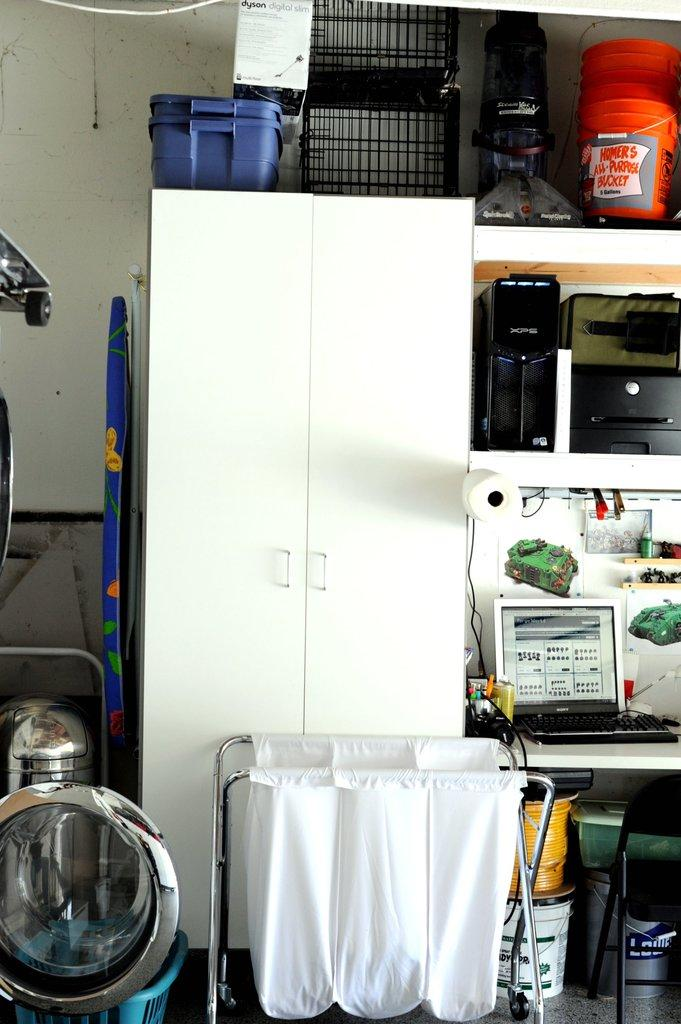<image>
Create a compact narrative representing the image presented. a utility room with various storage containers and orange buckets by HOMER"S 